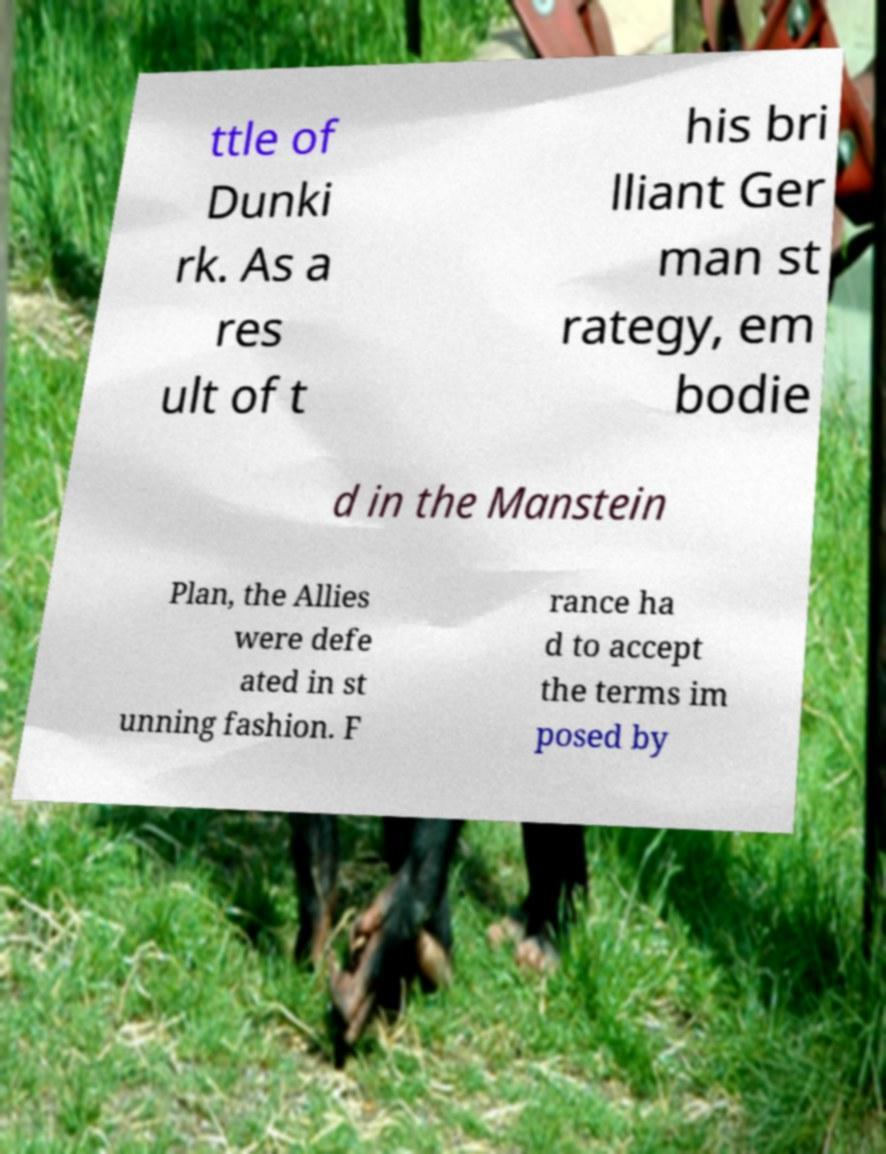For documentation purposes, I need the text within this image transcribed. Could you provide that? ttle of Dunki rk. As a res ult of t his bri lliant Ger man st rategy, em bodie d in the Manstein Plan, the Allies were defe ated in st unning fashion. F rance ha d to accept the terms im posed by 